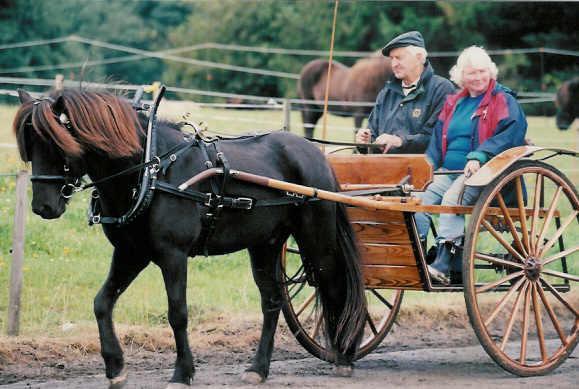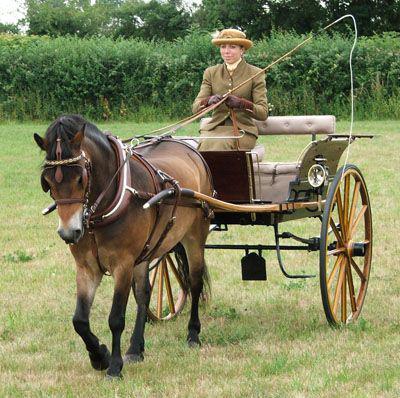The first image is the image on the left, the second image is the image on the right. Examine the images to the left and right. Is the description "A pony's mane hair is flying in the right image." accurate? Answer yes or no. No. The first image is the image on the left, the second image is the image on the right. Considering the images on both sides, is "There is no more than one person in the left image." valid? Answer yes or no. No. 